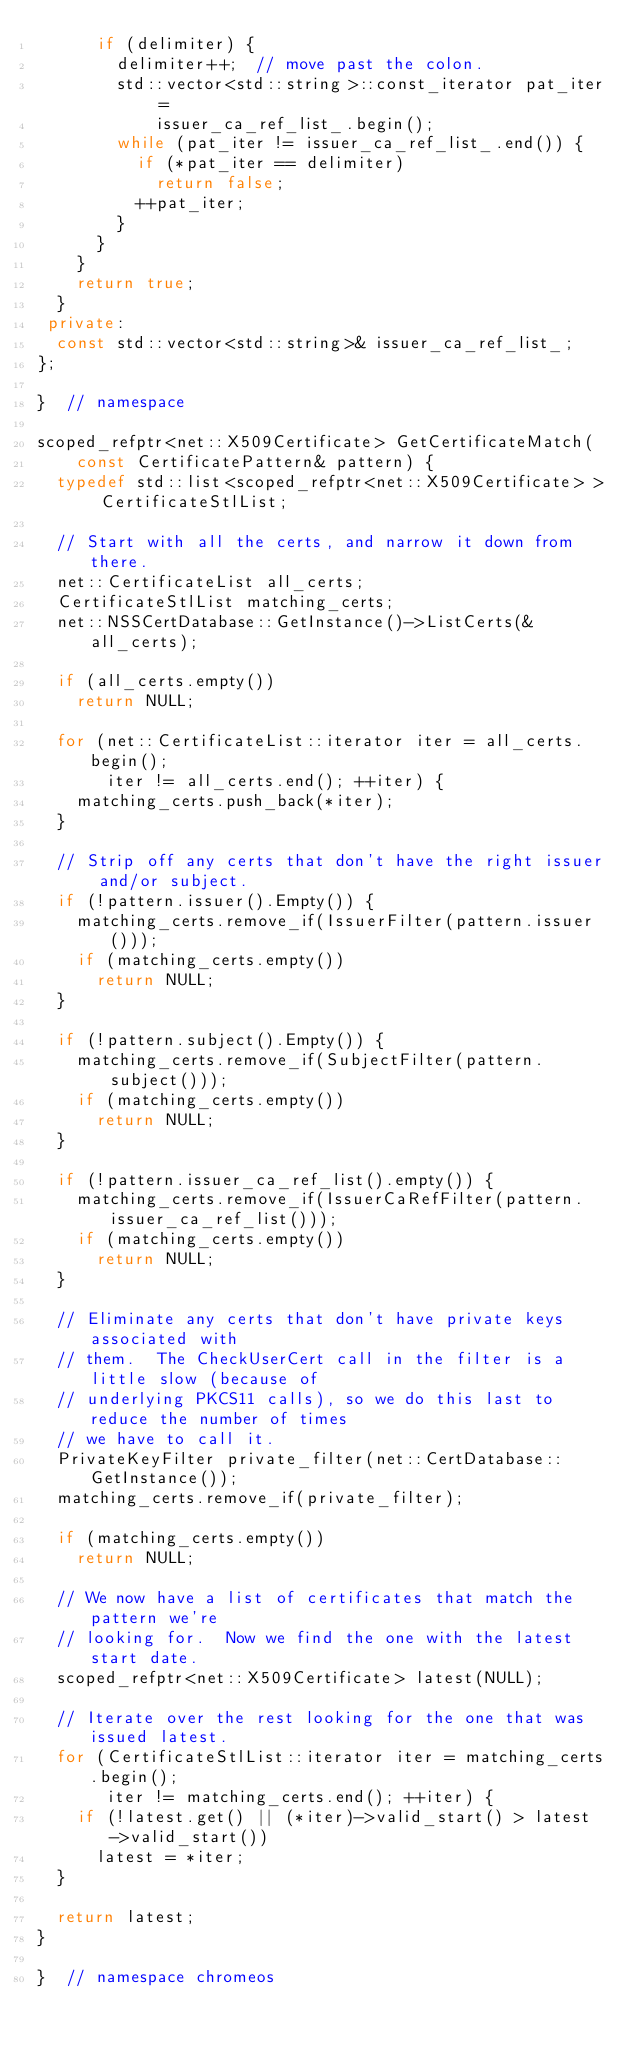<code> <loc_0><loc_0><loc_500><loc_500><_C++_>      if (delimiter) {
        delimiter++;  // move past the colon.
        std::vector<std::string>::const_iterator pat_iter =
            issuer_ca_ref_list_.begin();
        while (pat_iter != issuer_ca_ref_list_.end()) {
          if (*pat_iter == delimiter)
            return false;
          ++pat_iter;
        }
      }
    }
    return true;
  }
 private:
  const std::vector<std::string>& issuer_ca_ref_list_;
};

}  // namespace

scoped_refptr<net::X509Certificate> GetCertificateMatch(
    const CertificatePattern& pattern) {
  typedef std::list<scoped_refptr<net::X509Certificate> > CertificateStlList;

  // Start with all the certs, and narrow it down from there.
  net::CertificateList all_certs;
  CertificateStlList matching_certs;
  net::NSSCertDatabase::GetInstance()->ListCerts(&all_certs);

  if (all_certs.empty())
    return NULL;

  for (net::CertificateList::iterator iter = all_certs.begin();
       iter != all_certs.end(); ++iter) {
    matching_certs.push_back(*iter);
  }

  // Strip off any certs that don't have the right issuer and/or subject.
  if (!pattern.issuer().Empty()) {
    matching_certs.remove_if(IssuerFilter(pattern.issuer()));
    if (matching_certs.empty())
      return NULL;
  }

  if (!pattern.subject().Empty()) {
    matching_certs.remove_if(SubjectFilter(pattern.subject()));
    if (matching_certs.empty())
      return NULL;
  }

  if (!pattern.issuer_ca_ref_list().empty()) {
    matching_certs.remove_if(IssuerCaRefFilter(pattern.issuer_ca_ref_list()));
    if (matching_certs.empty())
      return NULL;
  }

  // Eliminate any certs that don't have private keys associated with
  // them.  The CheckUserCert call in the filter is a little slow (because of
  // underlying PKCS11 calls), so we do this last to reduce the number of times
  // we have to call it.
  PrivateKeyFilter private_filter(net::CertDatabase::GetInstance());
  matching_certs.remove_if(private_filter);

  if (matching_certs.empty())
    return NULL;

  // We now have a list of certificates that match the pattern we're
  // looking for.  Now we find the one with the latest start date.
  scoped_refptr<net::X509Certificate> latest(NULL);

  // Iterate over the rest looking for the one that was issued latest.
  for (CertificateStlList::iterator iter = matching_certs.begin();
       iter != matching_certs.end(); ++iter) {
    if (!latest.get() || (*iter)->valid_start() > latest->valid_start())
      latest = *iter;
  }

  return latest;
}

}  // namespace chromeos
</code> 